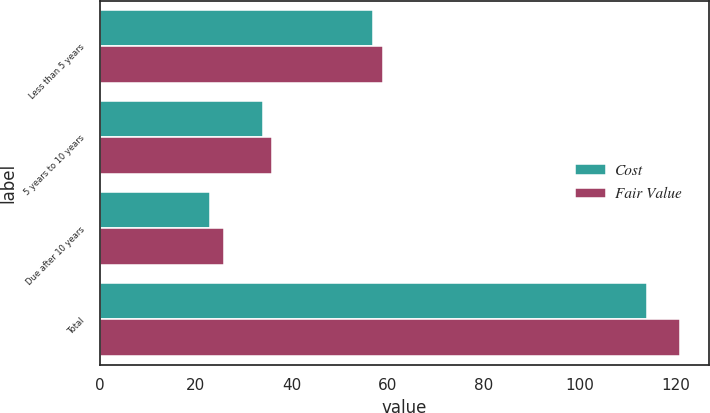Convert chart to OTSL. <chart><loc_0><loc_0><loc_500><loc_500><stacked_bar_chart><ecel><fcel>Less than 5 years<fcel>5 years to 10 years<fcel>Due after 10 years<fcel>Total<nl><fcel>Cost<fcel>57<fcel>34<fcel>23<fcel>114<nl><fcel>Fair Value<fcel>59<fcel>36<fcel>26<fcel>121<nl></chart> 